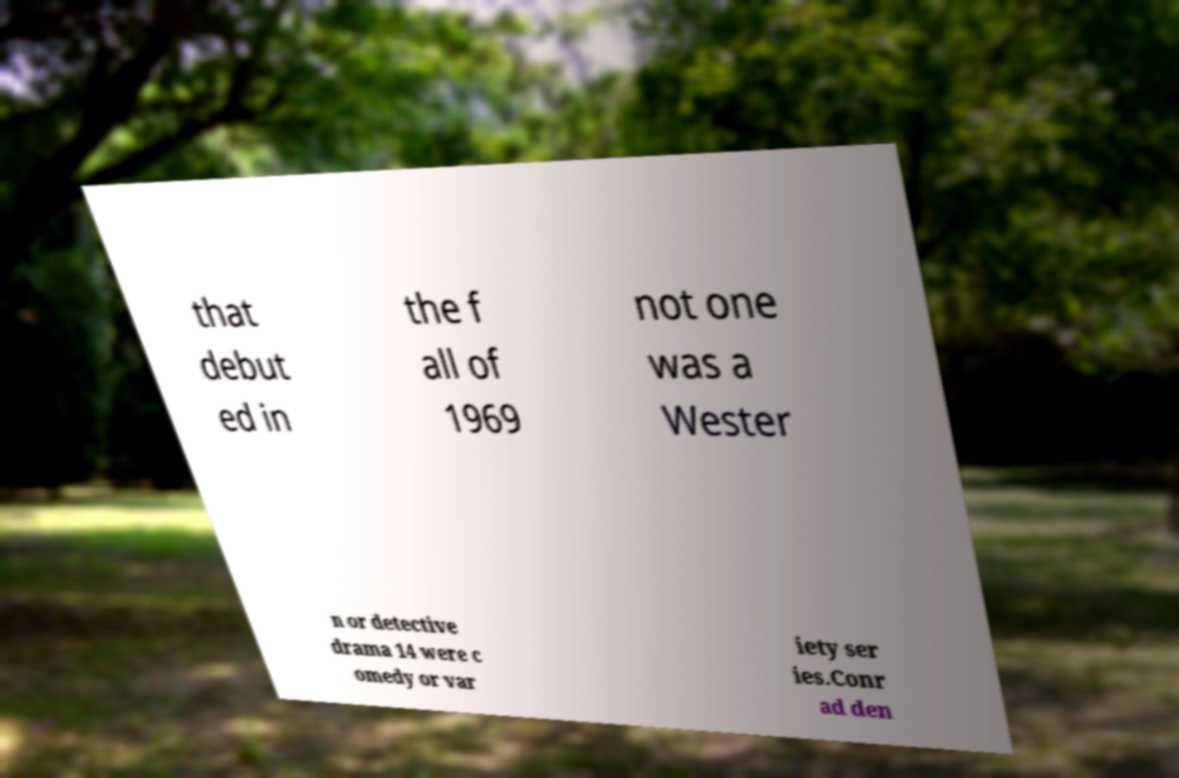Can you read and provide the text displayed in the image?This photo seems to have some interesting text. Can you extract and type it out for me? that debut ed in the f all of 1969 not one was a Wester n or detective drama 14 were c omedy or var iety ser ies.Conr ad den 